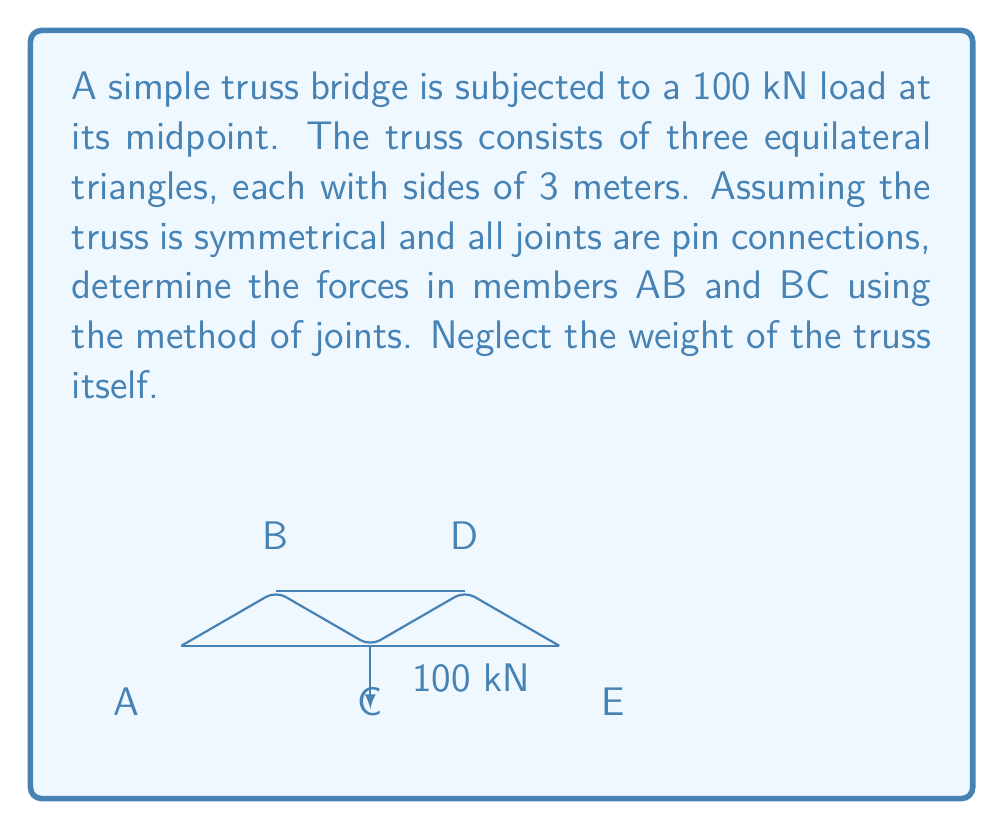What is the answer to this math problem? Let's solve this problem step by step:

1) First, we need to determine the reaction forces at the supports A and E. Due to symmetry, each support will bear half of the total load:

   $R_A = R_E = 50 \text{ kN}$ (upward)

2) Now, let's focus on joint B. We'll use the method of joints to set up our system of equations. Let $F_{AB}$ and $F_{BC}$ be the forces in members AB and BC respectively (tension positive, compression negative).

3) For equilibrium at joint B, we have:

   Vertical: $F_{AB} \sin 60° + F_{BC} = 50$
   Horizontal: $F_{AB} \cos 60° = 0$

4) From the horizontal equation:
   $F_{AB} \cos 60° = 0$
   $F_{AB} = 0$

5) Substituting this into the vertical equation:
   $0 + F_{BC} = 50$
   $F_{BC} = 50 \text{ kN}$

6) To verify, let's check the equilibrium at joint C:

   Vertical: $F_{BC} + F_{BC} = 100$
   $50 + 50 = 100$ (checks out)

   Horizontal: $F_{AC} \cos 30° = F_{CD} \cos 30°$
   $F_{AC} = F_{CD}$ (symmetry confirmed)

Therefore, the force in member AB is 0 kN (zero force member), and the force in member BC is 50 kN (compression).
Answer: $F_{AB} = 0 \text{ kN}, F_{BC} = -50 \text{ kN}$ 